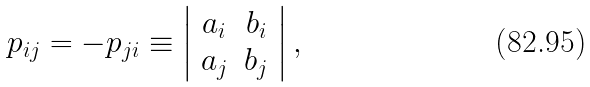<formula> <loc_0><loc_0><loc_500><loc_500>p _ { i j } = - p _ { j i } \equiv \left | \begin{array} { c c } a _ { i } & b _ { i } \\ a _ { j } & b _ { j } \end{array} \right | ,</formula> 